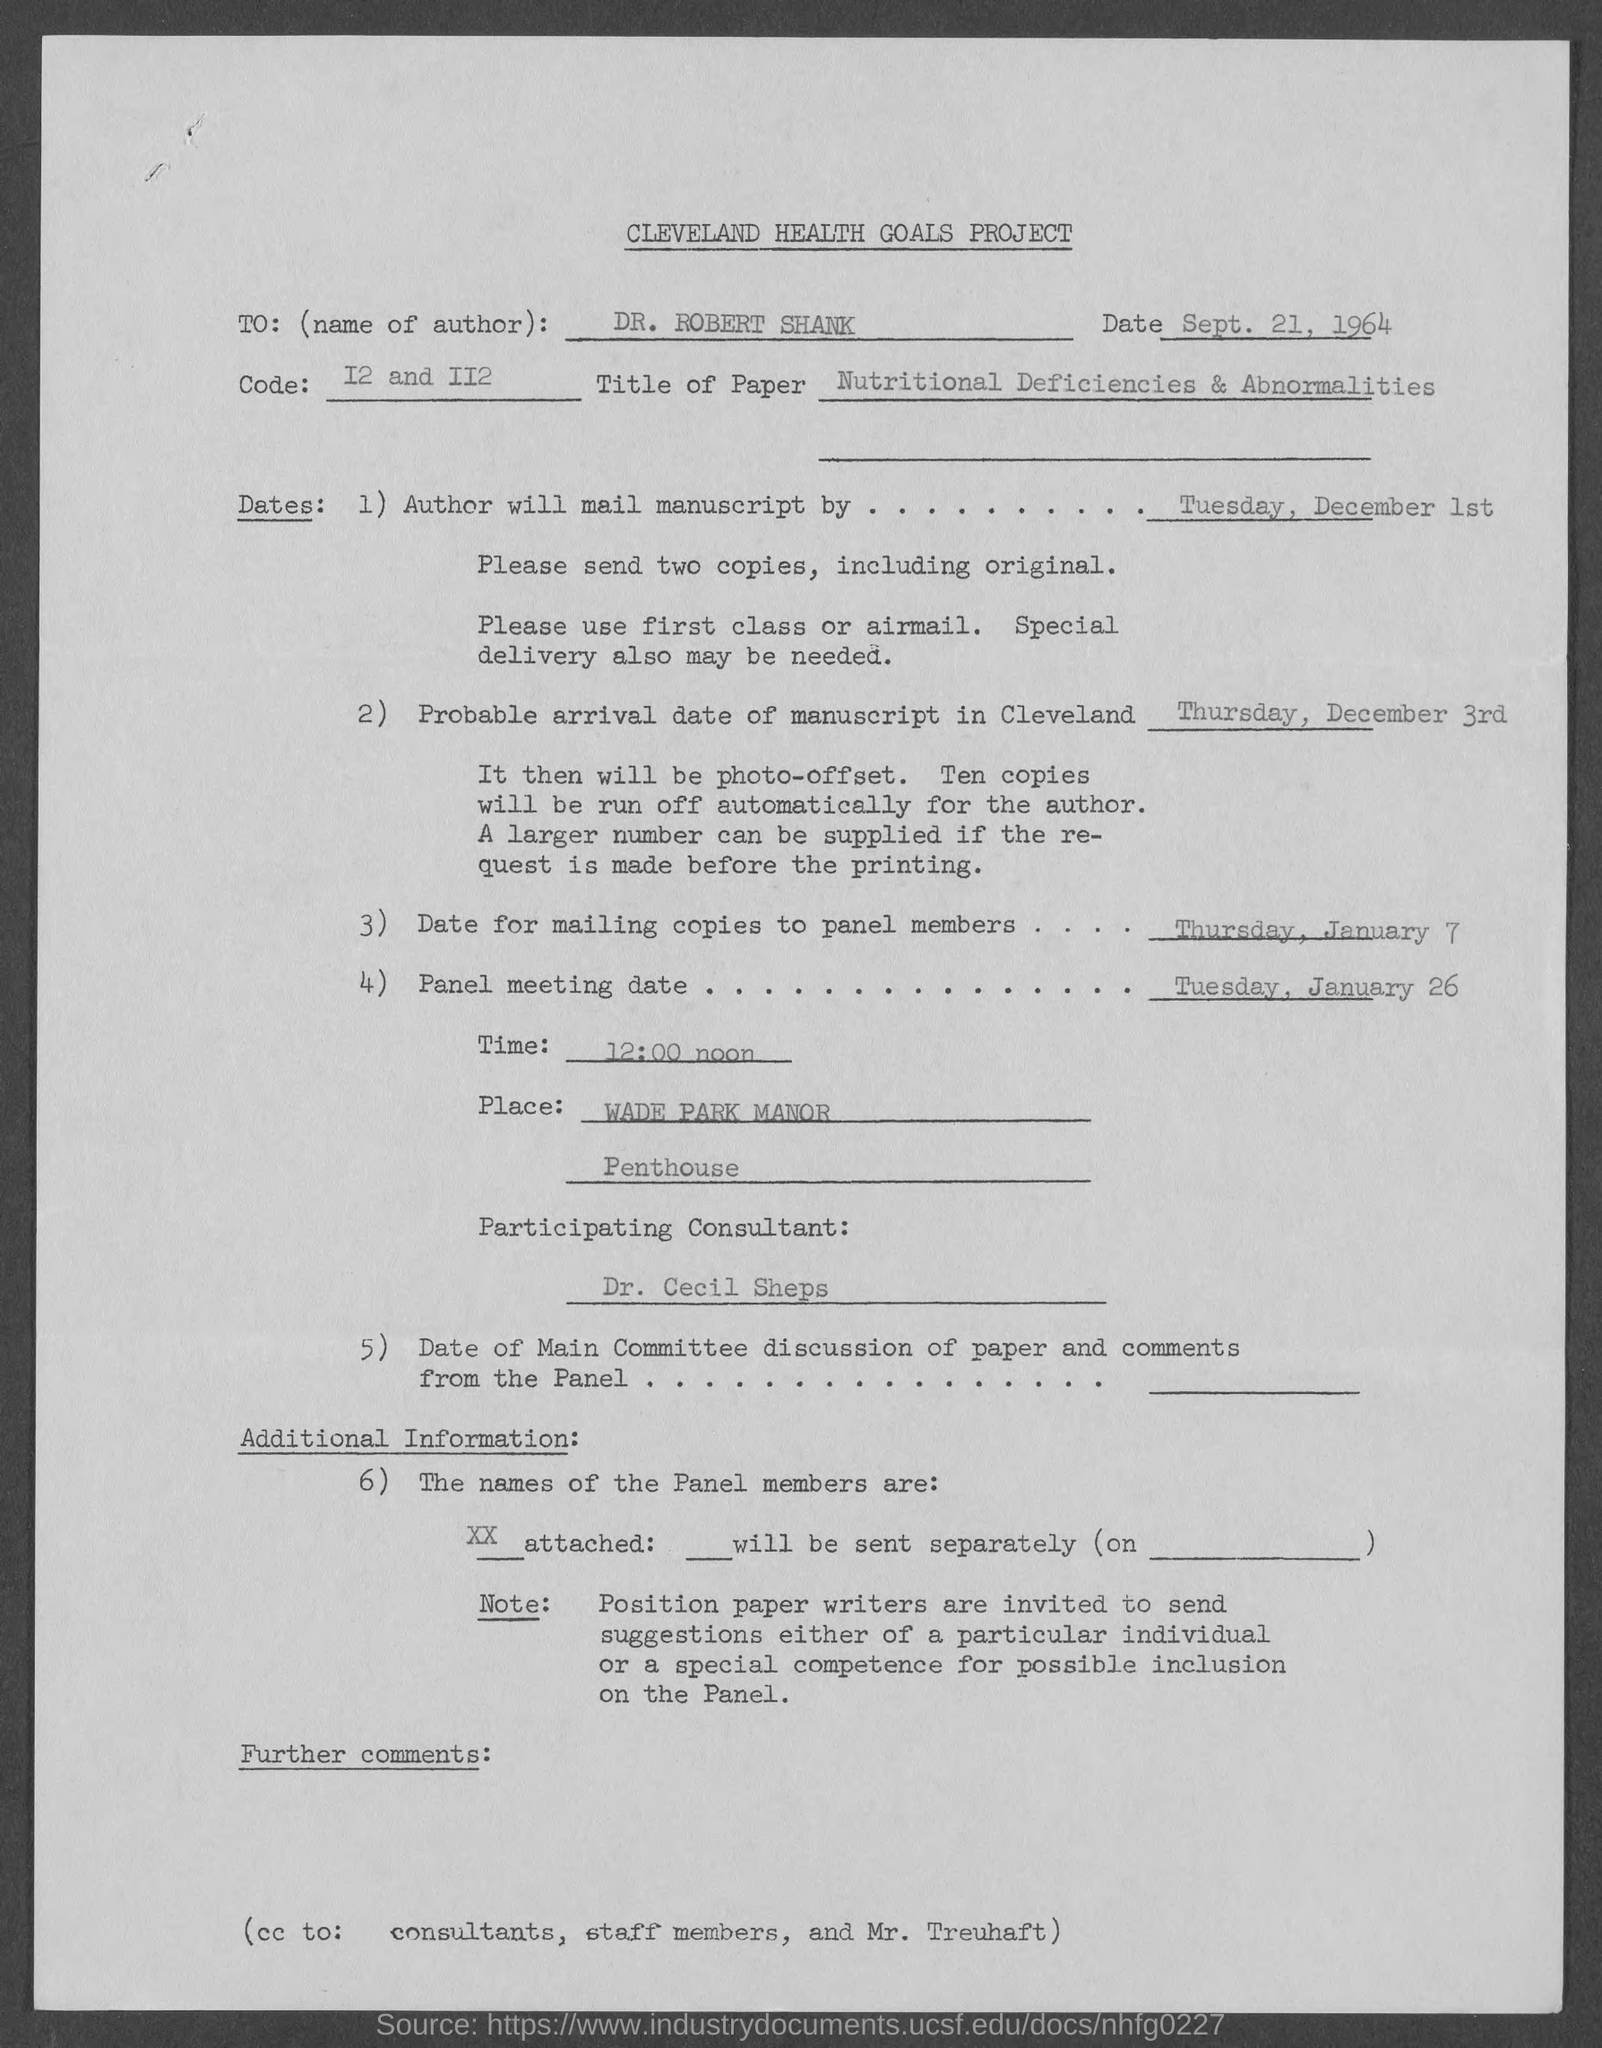What is the title of this document?
Offer a terse response. CLEVELAND HEALTH GOALS PROJECT. What is the name of the author mentioned in the document?
Provide a succinct answer. DR. ROBERT SHANK. What is the probable arrival date of manuscript in cleveland?
Offer a terse response. Thursday, December 3rd. What is the Title of the paper given in the document?
Offer a terse response. Nutritional Deficiencies & Abnormalities. What is the date for mailing copies to panel members?
Make the answer very short. Thursday, January 7. Who is the participating consultant in the panel meeting?
Offer a very short reply. Dr. Cecil Sheps. What is the panel meeting date given in the document?
Provide a short and direct response. Tuesday, January 26. In which place is the panel meeting organized?
Your response must be concise. WADE PARK MANOR. Who all are marked in the cc of this document?
Offer a terse response. (cc to: consultants, staff members, and Mr. Treuhaft). 